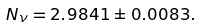Convert formula to latex. <formula><loc_0><loc_0><loc_500><loc_500>N _ { \nu } = { 2 . 9 8 4 1 \pm 0 . 0 0 8 3 } .</formula> 